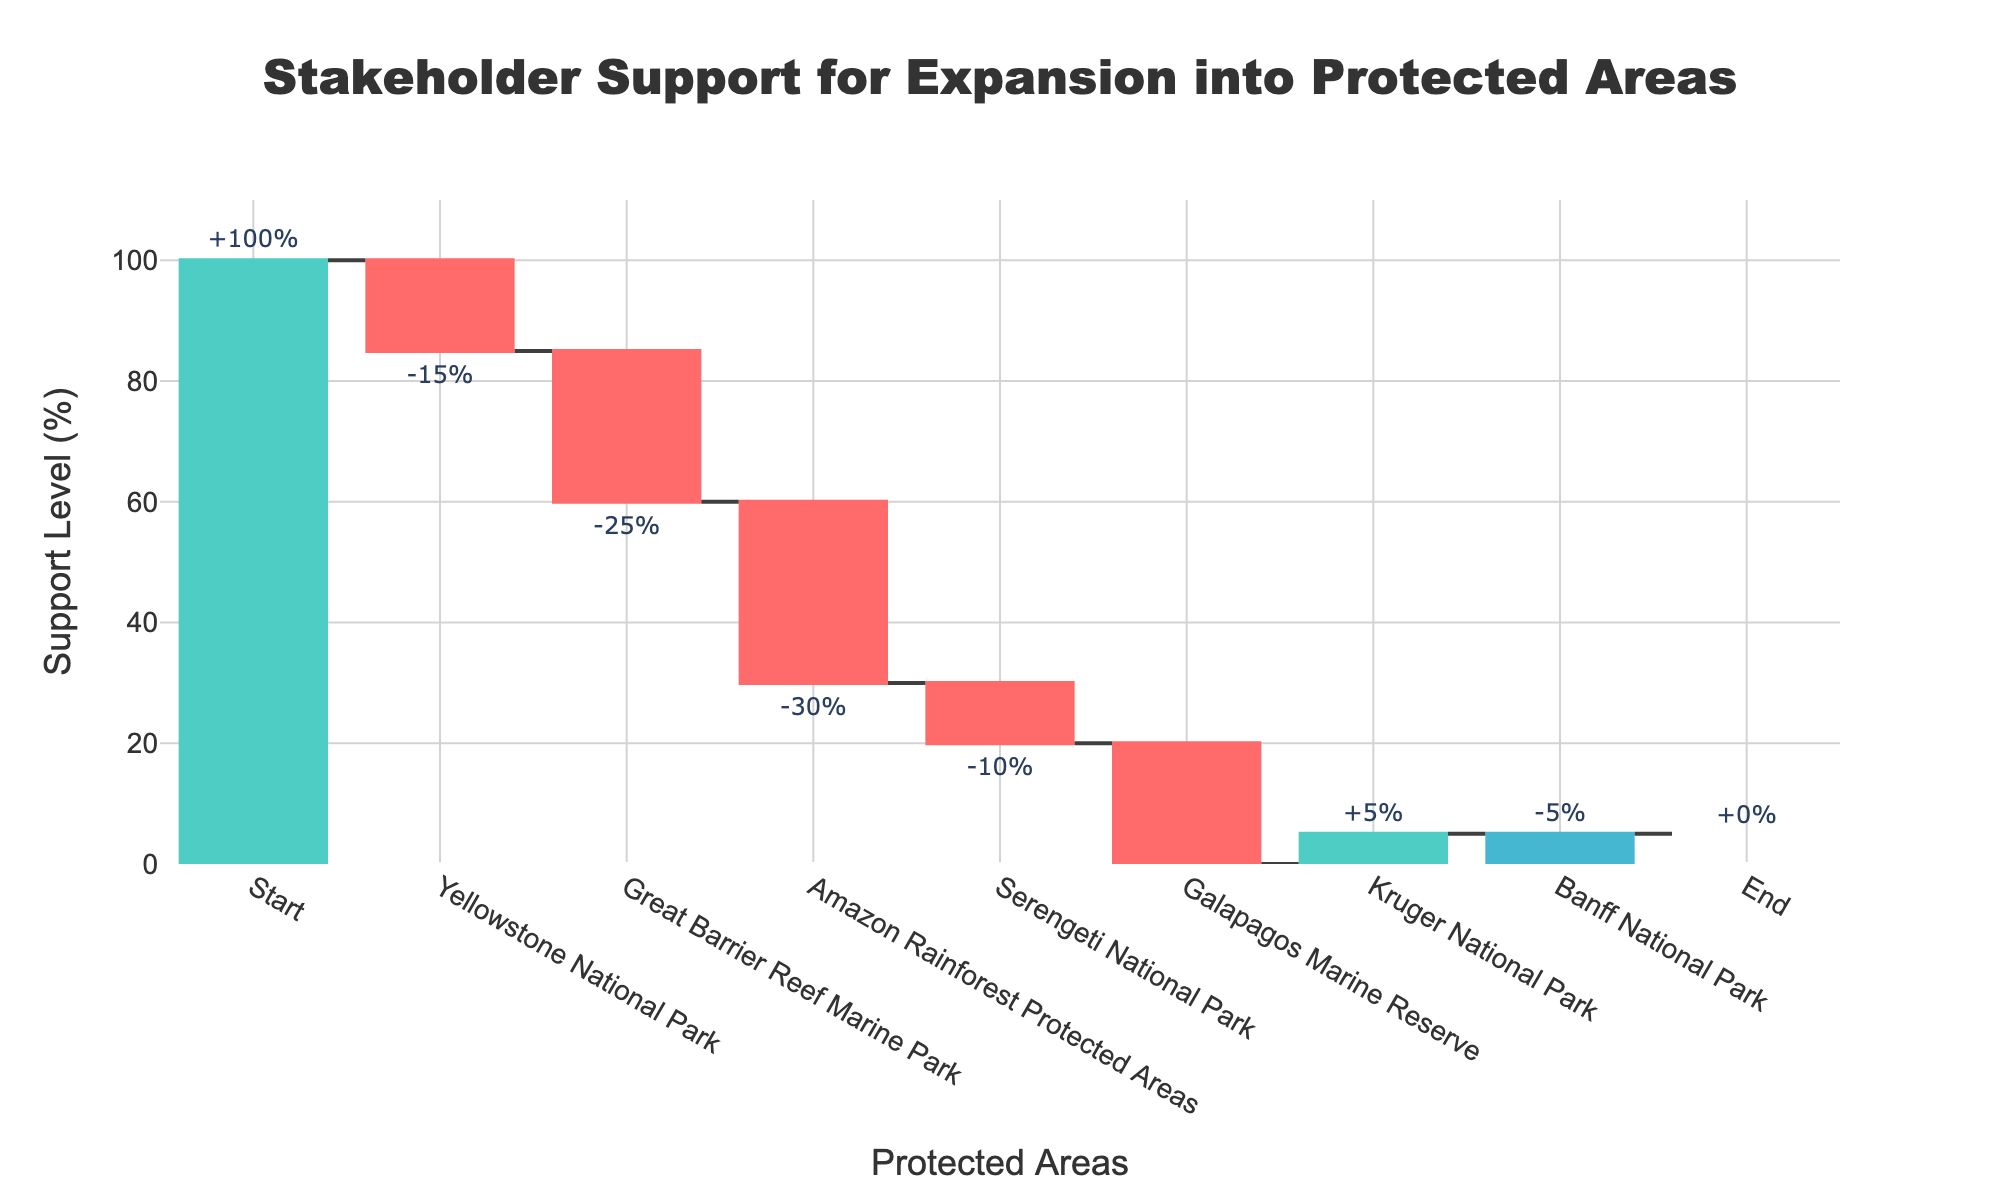What is the title of the chart? The title is displayed at the top of the chart, centered and bold. It summarizes the key information of the chart.
Answer: Stakeholder Support for Expansion into Protected Areas What is the support level for the Amazon Rainforest Protected Areas? The support levels are indicated by the bars with corresponding percentages. Locate the bar labeled "Amazon Rainforest Protected Areas" and read its value.
Answer: -30% What color is used for increasing support levels? The increasing support levels are indicated by the color of the bars that portray a positive change.
Answer: Green How many protected areas are listed in the chart? Count the individual categories excluding 'Start' and 'End' in the x-axis.
Answer: 7 What is the total combined decrease in support levels across all listed protected areas? Identify all the bars that show negative values and add up these values: -15 (Yellowstone) + -25 (Great Barrier Reef) + -30 (Amazon Rainforest) + -10 (Serengeti) + -20 (Galapagos) – 5 (Banff).
Answer: -100% What is the average change in support levels excluding the 'Start' and 'End' categories? Sum the values for all protected areas and divide by the number of areas (7). Calculate: (-15 + -25 + -30 + -10 + -20 + 5 + -5) / 7.
Answer: -14.29% Which protected area has the smallest decrease in support level? Compare the negative support values for all areas and identify the one with the smallest absolute value.
Answer: Serengeti National Park (-10%) Which protected area has a positive support level change? Check the support level values for each area for any positive numbers.
Answer: Kruger National Park (+5%) What is the cumulative support level after the Galapagos Marine Reserve? Track the cumulative sum shown visually on the chart up to the Galapagos Marine Reserve.
Answer: -95 How does the starting value compare to the ending value? Analyze the visual difference between the 'Start' and 'End' values to see how overall support has changed.
Answer: Start is 100%, End is 0% 